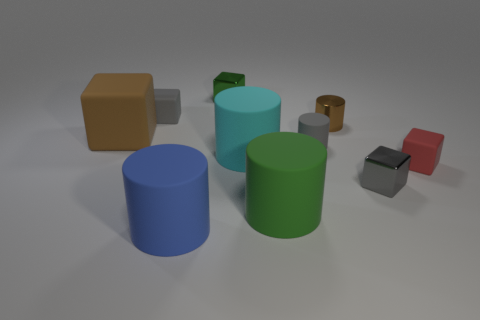Subtract all green cubes. How many cubes are left? 4 Subtract all large blue cylinders. How many cylinders are left? 4 Subtract all purple cylinders. Subtract all gray spheres. How many cylinders are left? 5 Add 8 brown matte objects. How many brown matte objects are left? 9 Add 1 metal cylinders. How many metal cylinders exist? 2 Subtract 1 red blocks. How many objects are left? 9 Subtract all tiny gray metallic blocks. Subtract all tiny blue matte balls. How many objects are left? 9 